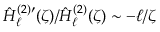<formula> <loc_0><loc_0><loc_500><loc_500>\hat { H } _ { \ell } ^ { ( 2 ) \prime } ( \zeta ) / \hat { H } _ { \ell } ^ { ( 2 ) } ( \zeta ) \sim - \ell / \zeta</formula> 